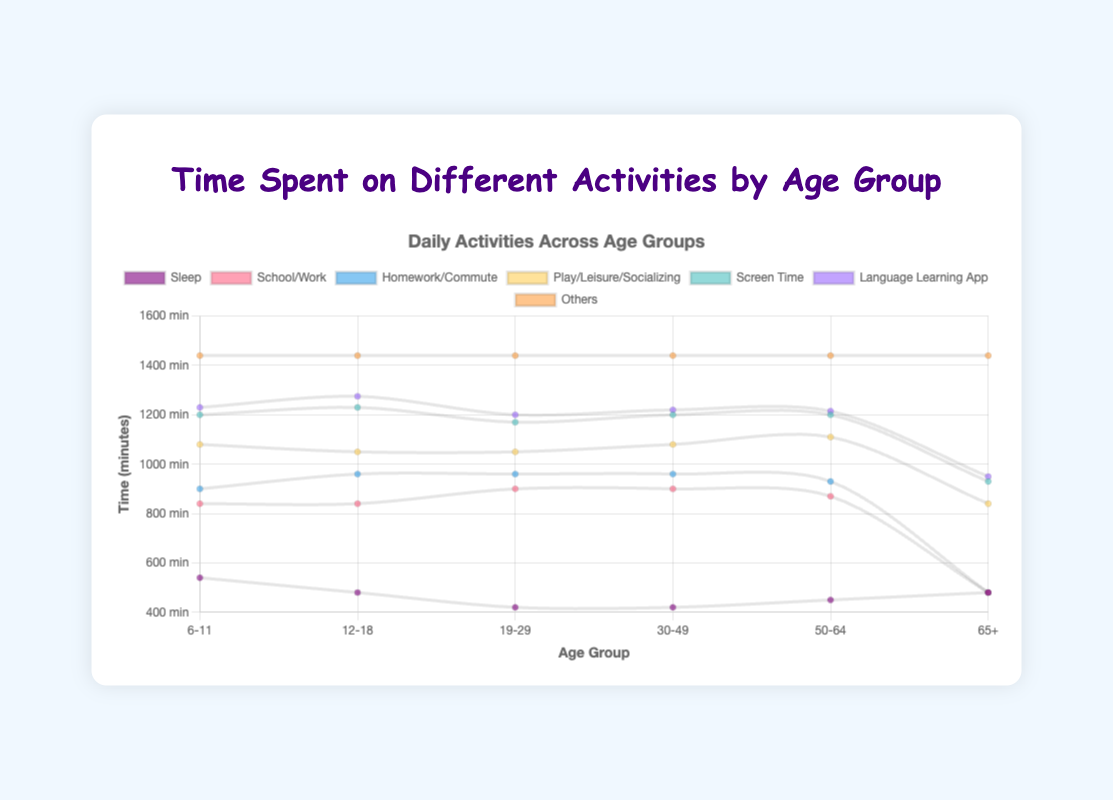What is the title of the chart? The title is displayed at the top of the chart in larger and bolder text.
Answer: Time Spent on Different Activities by Age Group How much time do people aged 30-49 spend on language learning apps? Look at the “Language Learning App” section for the 30-49 age group.
Answer: 20 minutes Which age group spends the most time on school or work activities? Compare the 'School/Work' values for each age group and identify the highest.
Answer: 19-29 and 30-49 age groups (both 480 minutes) Which category takes up the least time for the age group 50-64? Identify the smallest value in the 50-64 age group section.
Answer: Language Learning App (15 minutes) How much more time do people aged 6-11 spend on play compared to those aged 12-18? Subtract time spent on play for age 12-18 from time spent on play for age 6-11.
Answer: 180 - 90 = 90 minutes Which activity sees the most consistent amount of time across all age groups? Identify the activity with the least variation in the data values across all age groups.
Answer: Screen Time For the age group 6-11, what is the total time spent on screen time and school combined? Add the values for 'Screen Time' and 'School' for age group 6-11.
Answer: 120 + 300 = 420 minutes What is the average time spent sleeping across all age groups? Add the sleep times for all age groups and divide by the number of age groups.
Answer: (540 + 480 + 420 + 420 + 450 + 480) / 6 = 465 minutes Comparing ages 65+ and 50-64, which age group spends more time on leisure activities? Compare the 'Leisure' values for age groups 65+ and 50-64.
Answer: 65+ age group (240 minutes) How does the time spent on language learning apps change from age group 12-18 to 19-29? Compare the values for 'Language Learning App' in these two age groups.
Answer: Decreases by 15 minutes (45 - 30) 